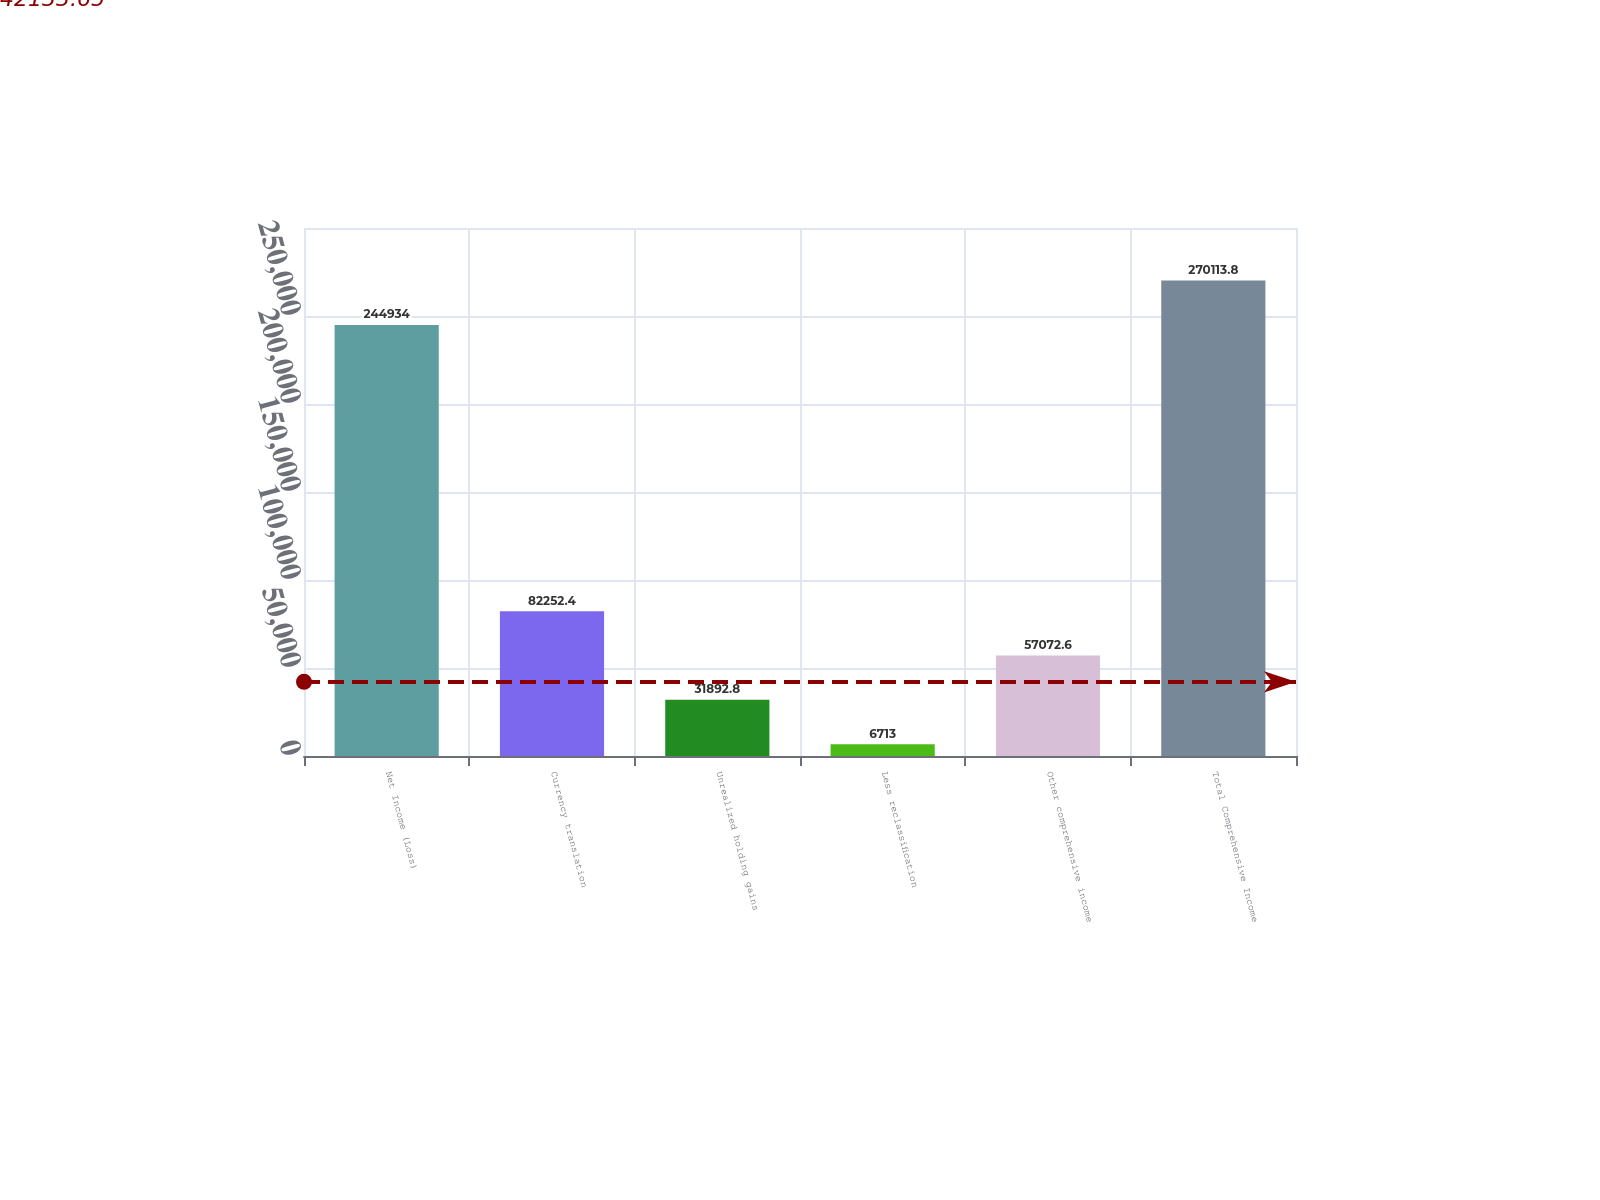Convert chart. <chart><loc_0><loc_0><loc_500><loc_500><bar_chart><fcel>Net Income (Loss)<fcel>Currency translation<fcel>Unrealized holding gains<fcel>Less reclassification<fcel>Other comprehensive income<fcel>Total Comprehensive Income<nl><fcel>244934<fcel>82252.4<fcel>31892.8<fcel>6713<fcel>57072.6<fcel>270114<nl></chart> 